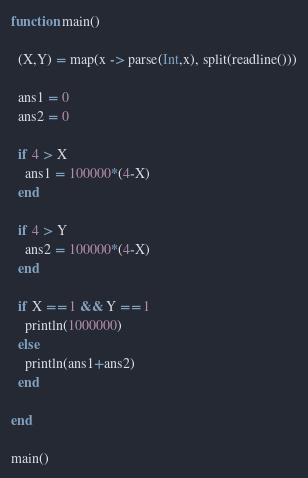Convert code to text. <code><loc_0><loc_0><loc_500><loc_500><_Julia_>function main()
  
  (X,Y) = map(x -> parse(Int,x), split(readline()))
  
  ans1 = 0
  ans2 = 0
  
  if 4 > X
    ans1 = 100000*(4-X)
  end
  
  if 4 > Y
    ans2 = 100000*(4-X)
  end
  
  if X == 1 && Y == 1
    println(1000000)
  else
    println(ans1+ans2)
  end
  
end

main()</code> 